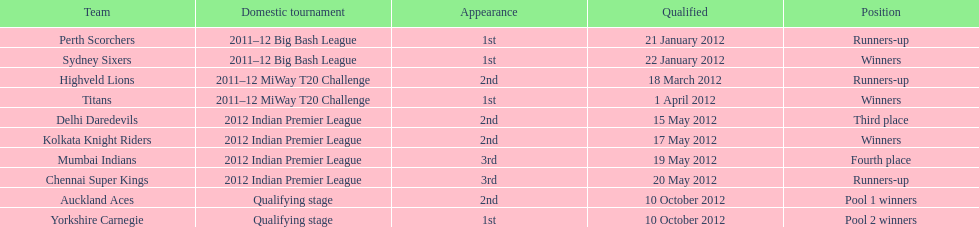Which team came in after the titans in the miway t20 challenge? Highveld Lions. 